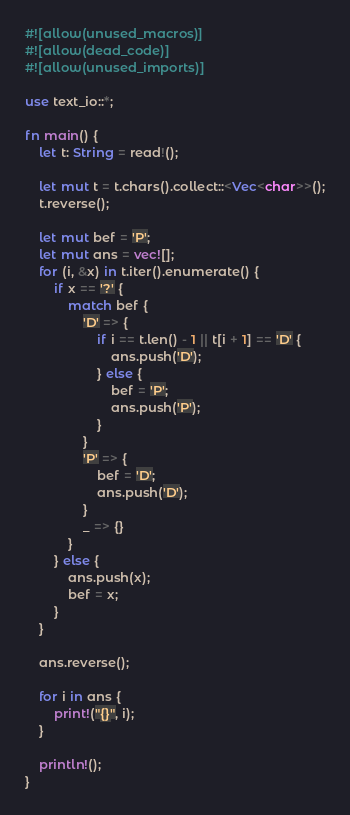Convert code to text. <code><loc_0><loc_0><loc_500><loc_500><_Rust_>#![allow(unused_macros)]
#![allow(dead_code)]
#![allow(unused_imports)]

use text_io::*;

fn main() {
    let t: String = read!();

    let mut t = t.chars().collect::<Vec<char>>();
    t.reverse();

    let mut bef = 'P';
    let mut ans = vec![];
    for (i, &x) in t.iter().enumerate() {
        if x == '?' {
            match bef {
                'D' => {
                    if i == t.len() - 1 || t[i + 1] == 'D' {
                        ans.push('D');
                    } else {
                        bef = 'P';
                        ans.push('P');
                    }
                }
                'P' => {
                    bef = 'D';
                    ans.push('D');
                }
                _ => {}
            }
        } else {
            ans.push(x);
            bef = x;
        }
    }

    ans.reverse();

    for i in ans {
        print!("{}", i);
    }

    println!();
}
</code> 